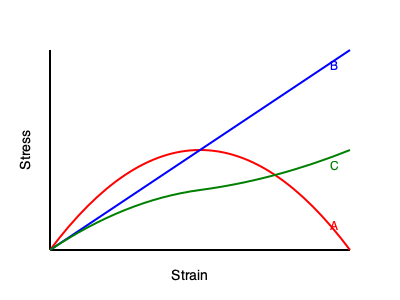The graph shows stress-strain curves for three different materials (A, B, and C). Which material exhibits the highest elastic modulus (Young's modulus), and what does this indicate about its behavior under stress? To determine which material has the highest elastic modulus, we need to analyze the stress-strain curves:

1. The elastic modulus (Young's modulus) is defined as the slope of the linear portion of the stress-strain curve in the elastic region.

2. It can be expressed mathematically as:

   $E = \frac{\Delta \sigma}{\Delta \epsilon}$

   Where $E$ is the elastic modulus, $\Delta \sigma$ is the change in stress, and $\Delta \epsilon$ is the change in strain.

3. Examining the curves:
   - Material A (red): Shows a non-linear curve, typical of elastomers or rubber-like materials.
   - Material B (blue): Exhibits a straight line with the steepest slope.
   - Material C (green): Displays an initial linear region followed by a non-linear region, typical of ductile metals.

4. The steeper the slope in the elastic region, the higher the elastic modulus.

5. Material B has the steepest slope, indicating it has the highest elastic modulus among the three materials.

6. A high elastic modulus indicates:
   - The material is stiffer and more resistant to elastic deformation.
   - It requires more stress to produce a given amount of elastic strain.
   - The material will experience smaller elastic deformations under a given stress compared to materials with lower elastic moduli.

Therefore, Material B exhibits the highest elastic modulus, indicating it is the stiffest material and will deform the least under a given stress in the elastic region.
Answer: Material B; highest stiffness and resistance to elastic deformation. 